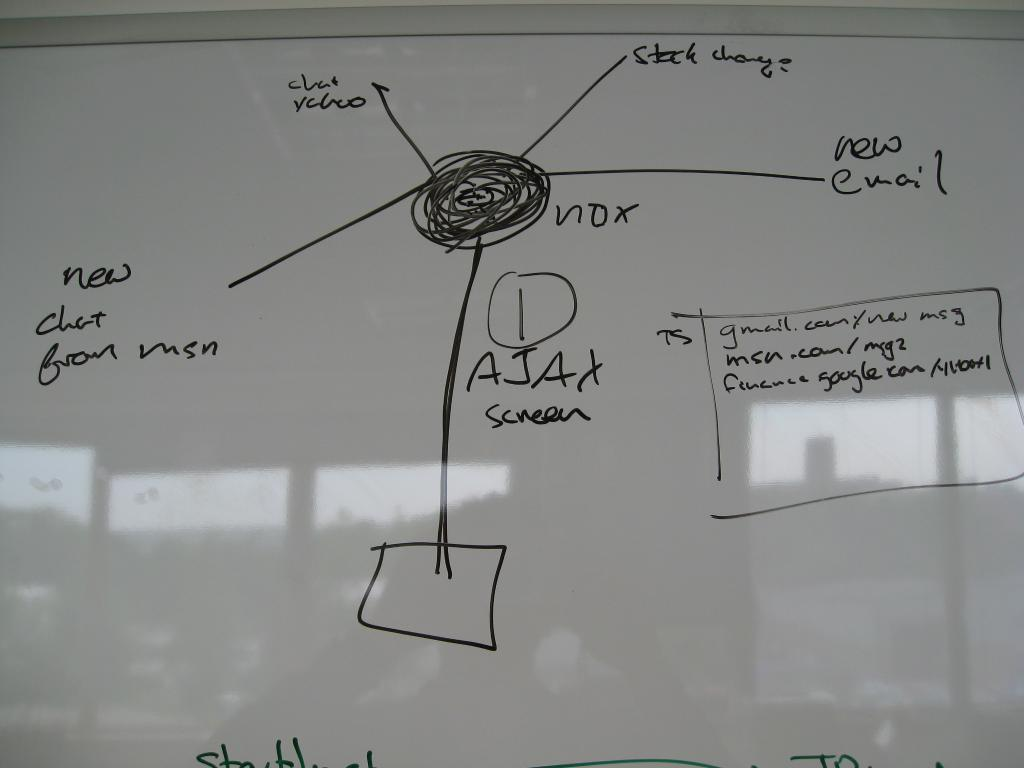What is the main object in the image? There is a whiteboard in the image. What is depicted on the whiteboard? The whiteboard contains images. How are the images or notations marked on the whiteboard? Notations are written on the whiteboard using a black marker. How many trucks are parked next to the whiteboard in the image? There are no trucks visible in the image; it only features a whiteboard with images and notations. What color is the eye on the whiteboard? There is no eye depicted on the whiteboard in the image. 